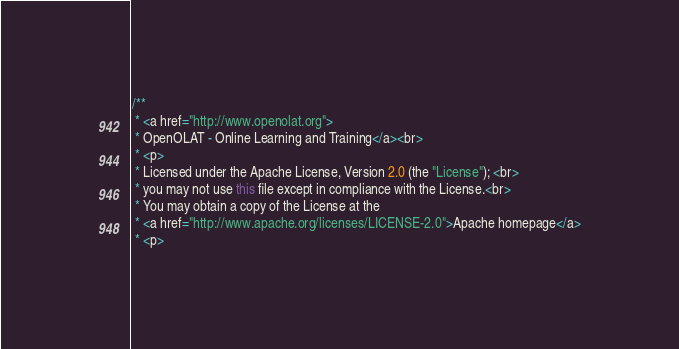Convert code to text. <code><loc_0><loc_0><loc_500><loc_500><_Java_>/**
 * <a href="http://www.openolat.org">
 * OpenOLAT - Online Learning and Training</a><br>
 * <p>
 * Licensed under the Apache License, Version 2.0 (the "License"); <br>
 * you may not use this file except in compliance with the License.<br>
 * You may obtain a copy of the License at the
 * <a href="http://www.apache.org/licenses/LICENSE-2.0">Apache homepage</a>
 * <p></code> 